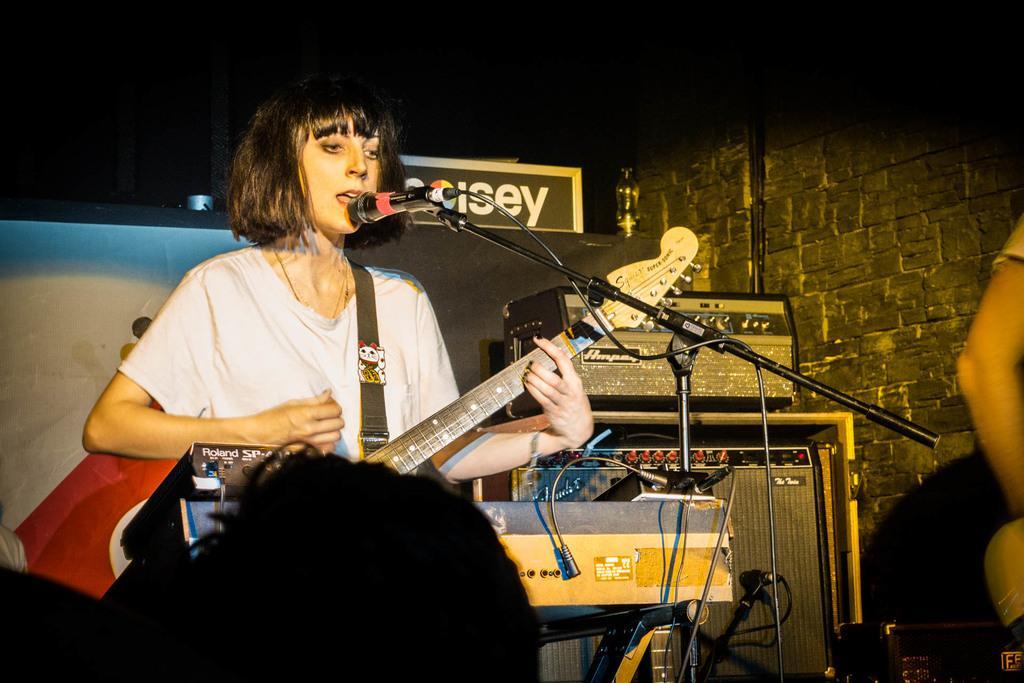Can you describe this image briefly? In this picture we can see woman holding guitar in her hands and singing on mic and in front of her we can see some persons and in background we can see devices, speakers, wall, banner. 